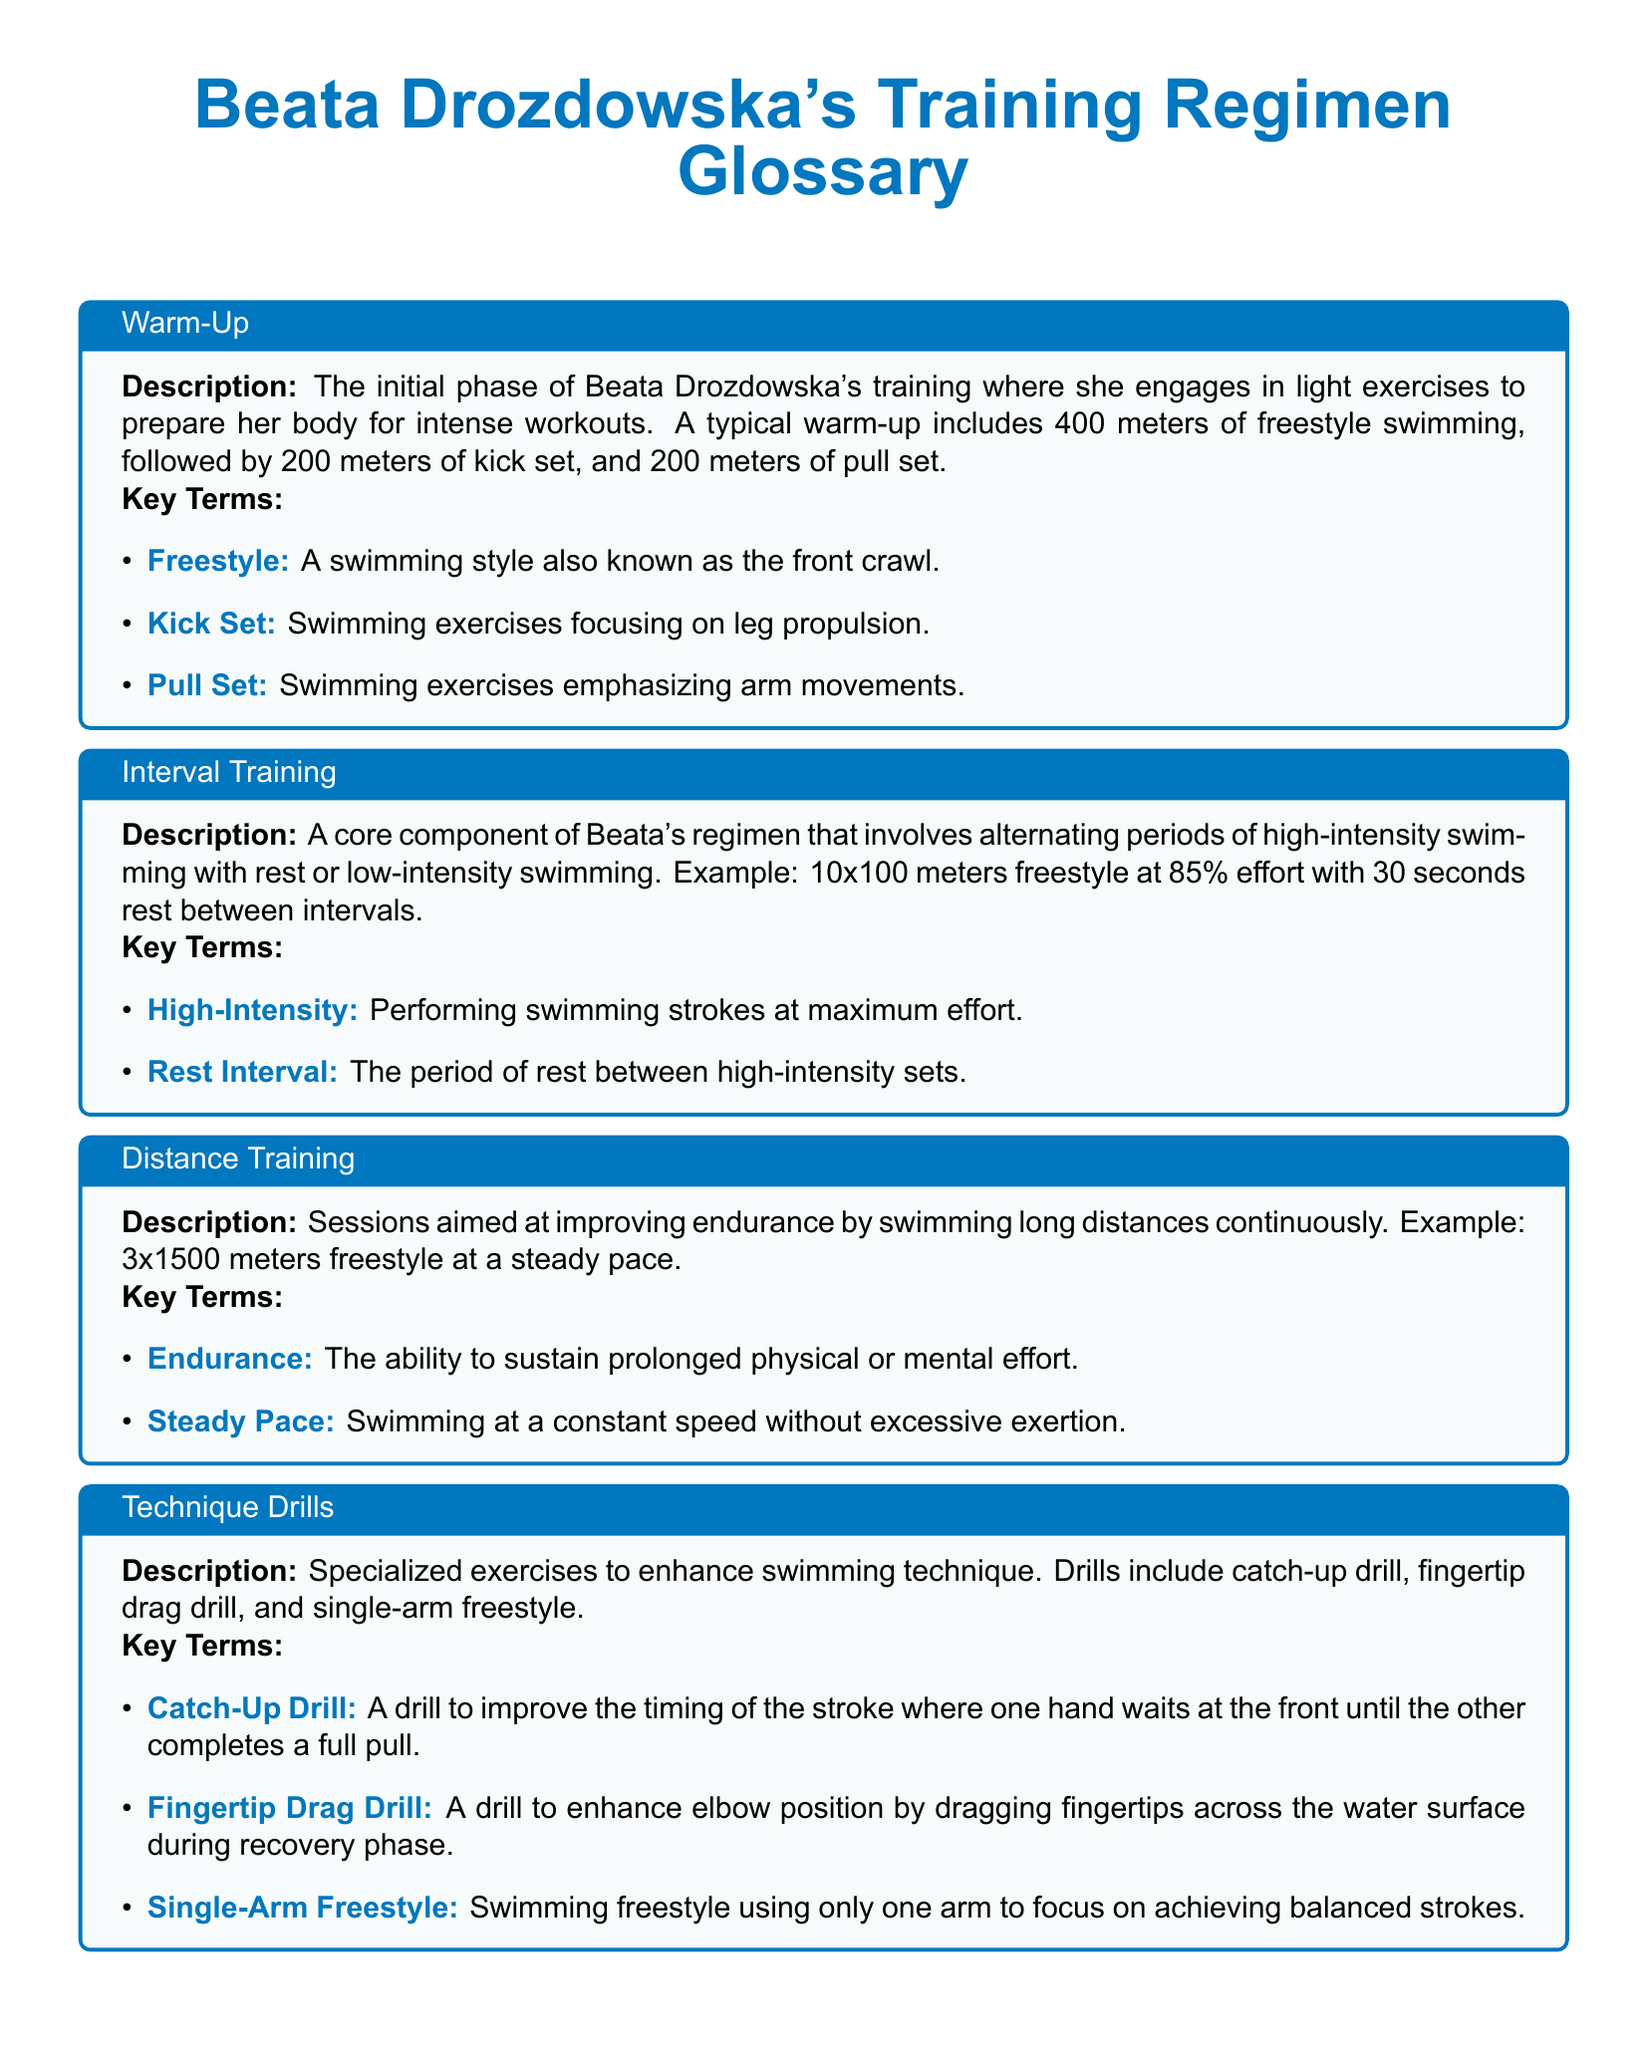What is the total distance covered in a typical warm-up? The warm-up includes 400 meters of freestyle swimming, 200 meters of kick set, and 200 meters of pull set. Thus, the total distance is calculated as 400 + 200 + 200 = 800 meters.
Answer: 800 meters What type of swimming style is referred to as freestyle? The document defines freestyle as a swimming style also known as the front crawl.
Answer: front crawl How many intervals are included in the interval training example? The example indicates 10x100 meters freestyle for the interval training session.
Answer: 10 What is the focus of the technique drills? The technique drills are specialized exercises aimed at enhancing swimming technique.
Answer: enhancing swimming technique What is the duration of the rest intervals in the anaerobic threshold training example? The example provides that there is a 1-minute rest interval between sets in the anaerobic threshold training.
Answer: 1 minute What are recovery sessions meant to facilitate? Recovery sessions are designed to facilitate muscle recovery through low-intensity swims and activities.
Answer: muscle recovery What type of sets does the sprint sets training focus on? The description mentions that sprint sets training is focused on developing maximum speed over short distances.
Answer: maximum speed What is the purpose of the warm-up phase? The warm-up phase prepares Beata Drozdowska's body for intense workouts through light exercises.
Answer: prepare for intense workouts 